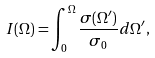Convert formula to latex. <formula><loc_0><loc_0><loc_500><loc_500>I ( \Omega ) = \int _ { 0 } ^ { \Omega } \frac { \sigma ( \Omega ^ { \prime } ) } { \sigma _ { 0 } } d \Omega ^ { \prime } ,</formula> 